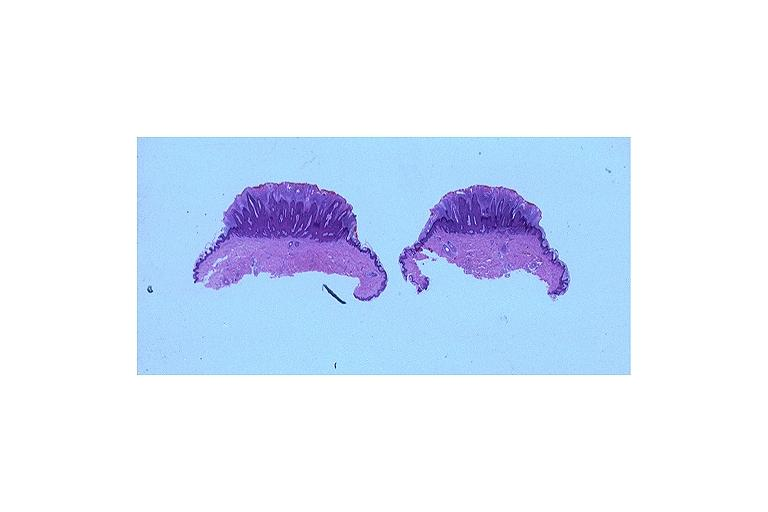s oral present?
Answer the question using a single word or phrase. Yes 